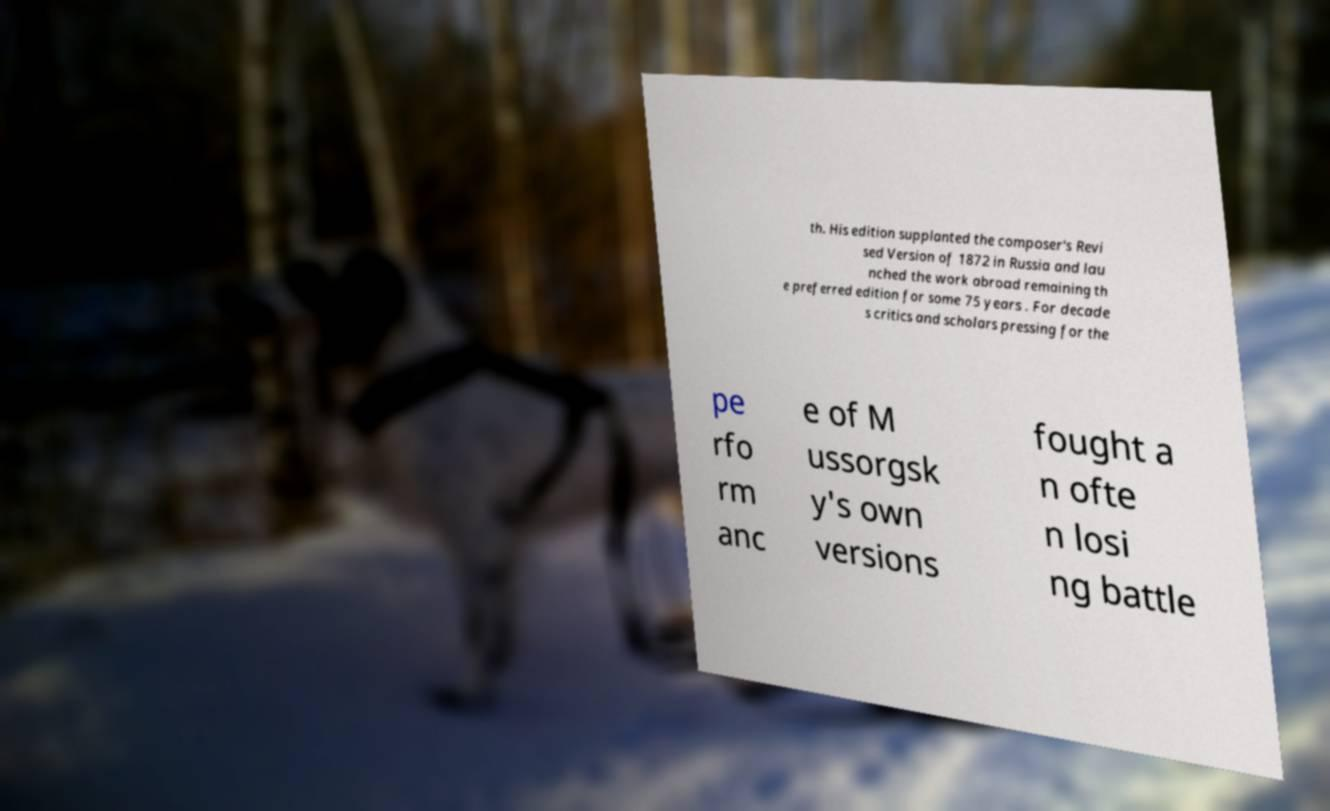There's text embedded in this image that I need extracted. Can you transcribe it verbatim? th. His edition supplanted the composer's Revi sed Version of 1872 in Russia and lau nched the work abroad remaining th e preferred edition for some 75 years . For decade s critics and scholars pressing for the pe rfo rm anc e of M ussorgsk y's own versions fought a n ofte n losi ng battle 